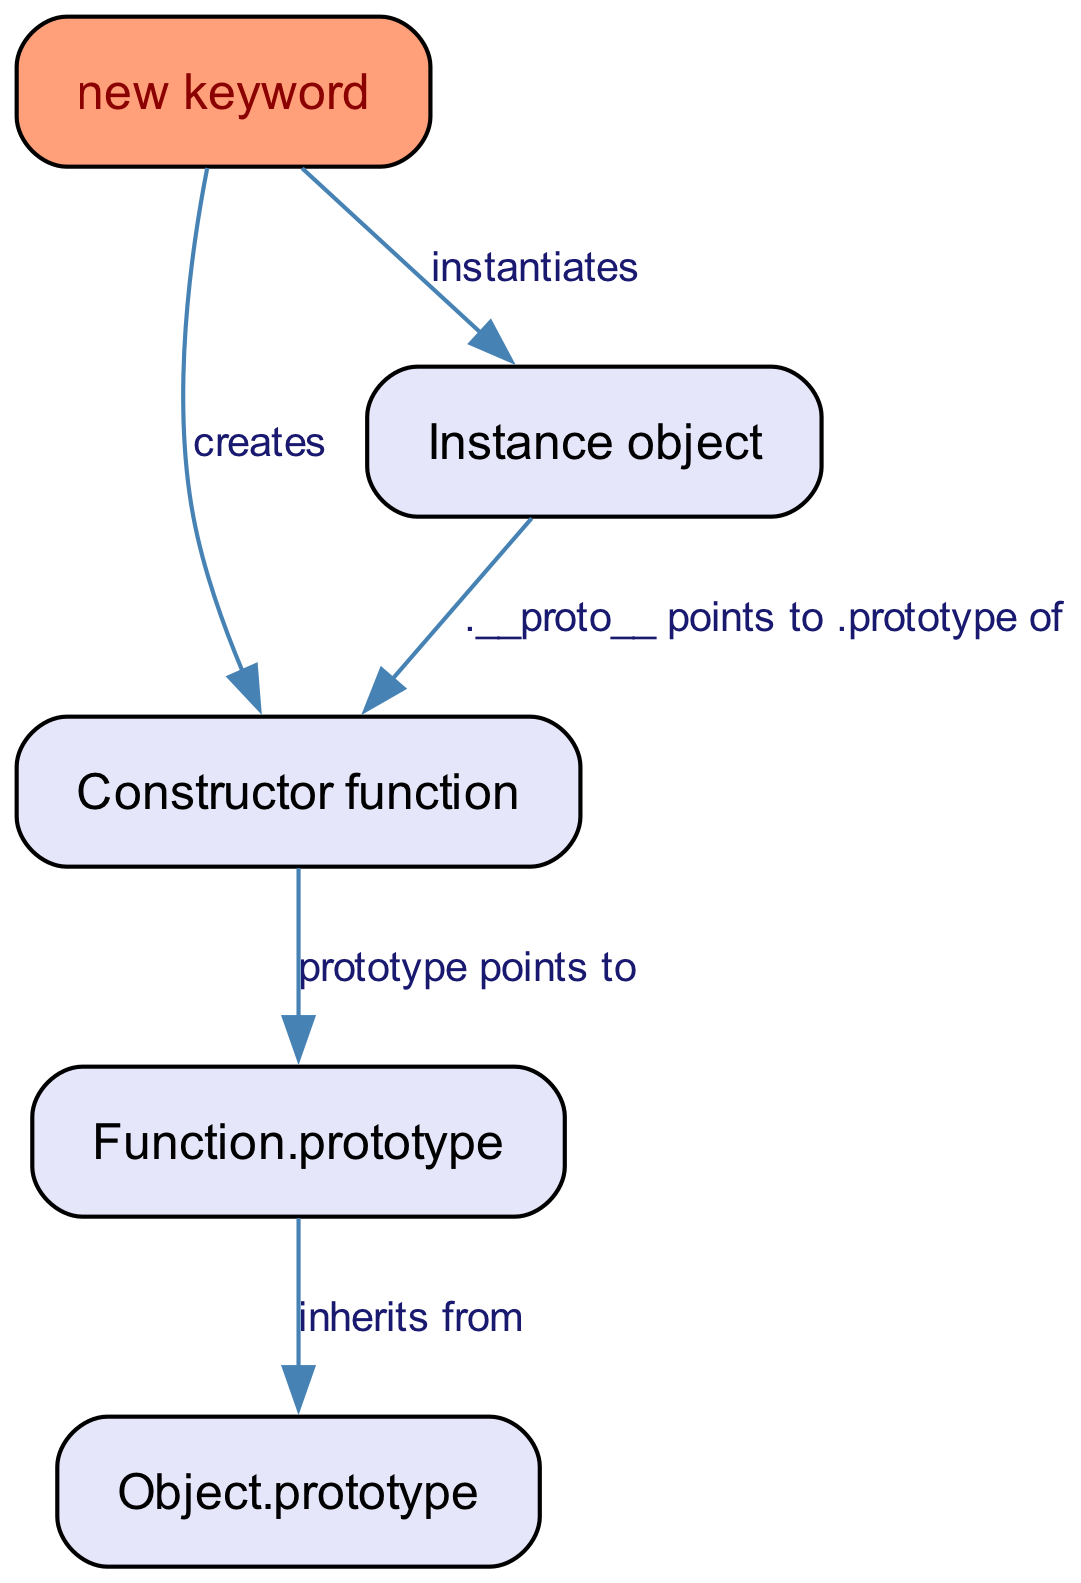What is the root of the prototype chain? The root of the prototype chain is represented by the node labelled "Object.prototype", as it is the top-most object from which all other objects inherit.
Answer: Object.prototype How many edges are there in this diagram? The diagram shows a total of 5 edges connecting various nodes, indicating the relationships between them.
Answer: 5 What relationship does "Function.prototype" have with "Object.prototype"? "Function.prototype" inherits from "Object.prototype", which is indicated by the edge connecting the two nodes with the label "inherits from".
Answer: inherits from What does the "new keyword" create? The "new keyword" creates a "Constructor function", as specified by the edge labelled "creates" that points from the "new keyword" to the "Constructor function".
Answer: Constructor function Which node points to "Instance object"? The "new keyword" points to the "Instance object", as shown by the directed edge labelled "instantiates" that connects them.
Answer: new keyword What is the relationship between "Instance object" and "Constructor function"? The relationship is that "Instance object" has a __proto__ that points to the "Constructor function", representing the prototypal inheritance chain.
Answer: .__proto__ points to .prototype of Which node has a special style in the diagram? The node labelled "new keyword" has a special style with a different fill color and font color, distinguishing it from the other nodes.
Answer: new keyword What does the "prototype" of the "Constructor function" point to? The "prototype" of the "Constructor function" points to "Function.prototype", establishing a direct relationship in the prototype chain.
Answer: Function.prototype What is the final instantiation represented in the diagram? The final instantiation represented is the creation of the "Instance object". This is the result of using the "new keyword" in the diagram.
Answer: Instance object 